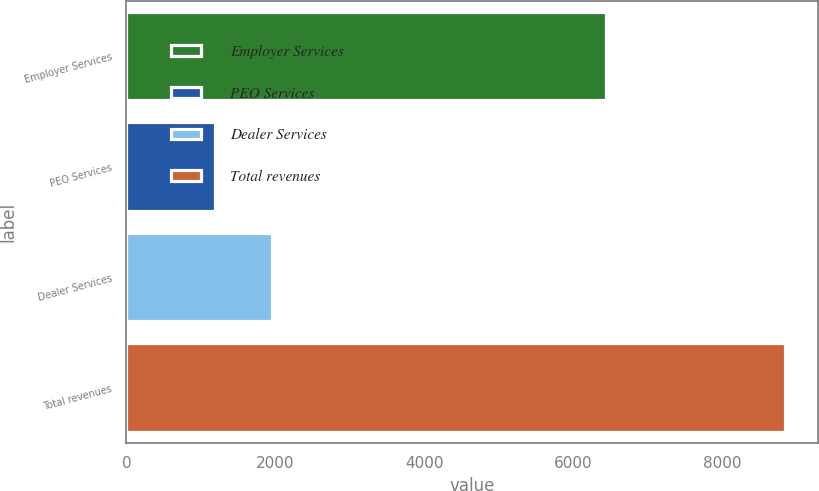Convert chart. <chart><loc_0><loc_0><loc_500><loc_500><bar_chart><fcel>Employer Services<fcel>PEO Services<fcel>Dealer Services<fcel>Total revenues<nl><fcel>6438.9<fcel>1185.8<fcel>1951.06<fcel>8838.4<nl></chart> 